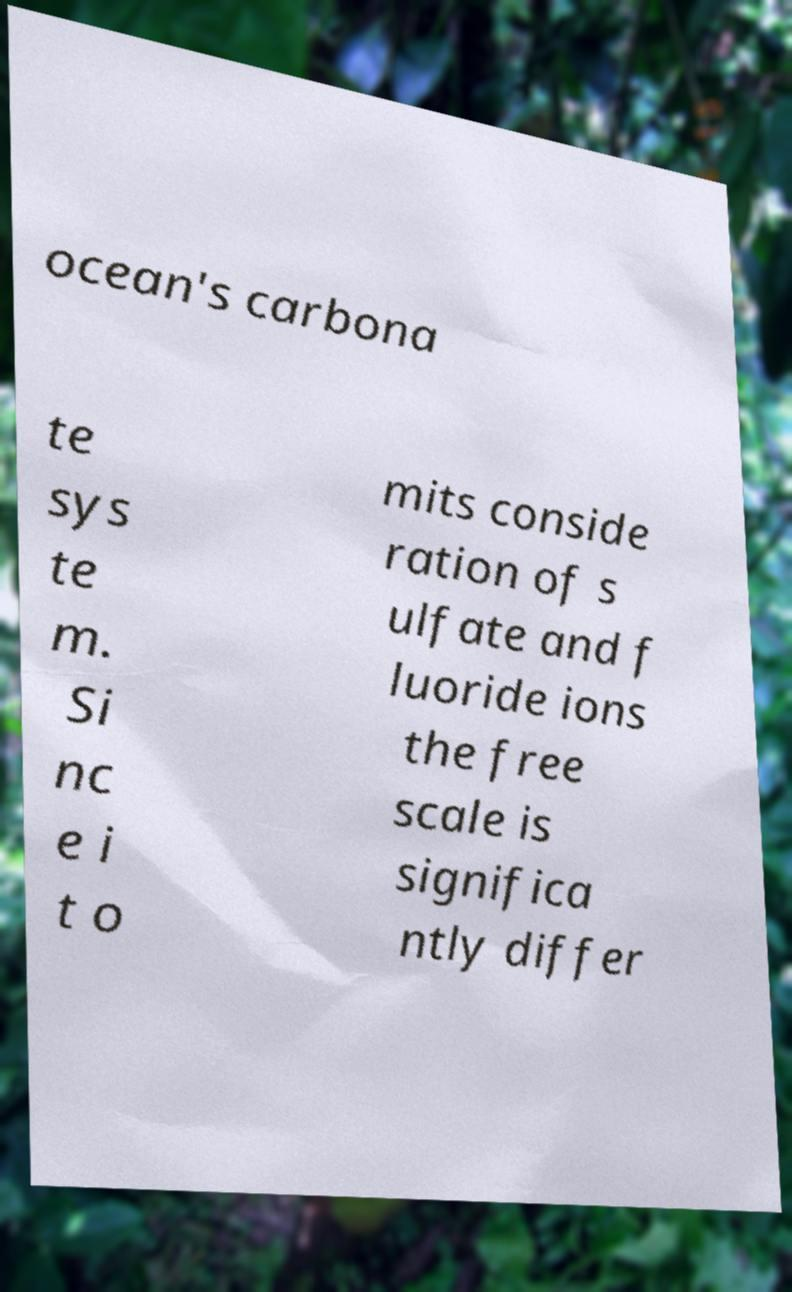Could you extract and type out the text from this image? ocean's carbona te sys te m. Si nc e i t o mits conside ration of s ulfate and f luoride ions the free scale is significa ntly differ 